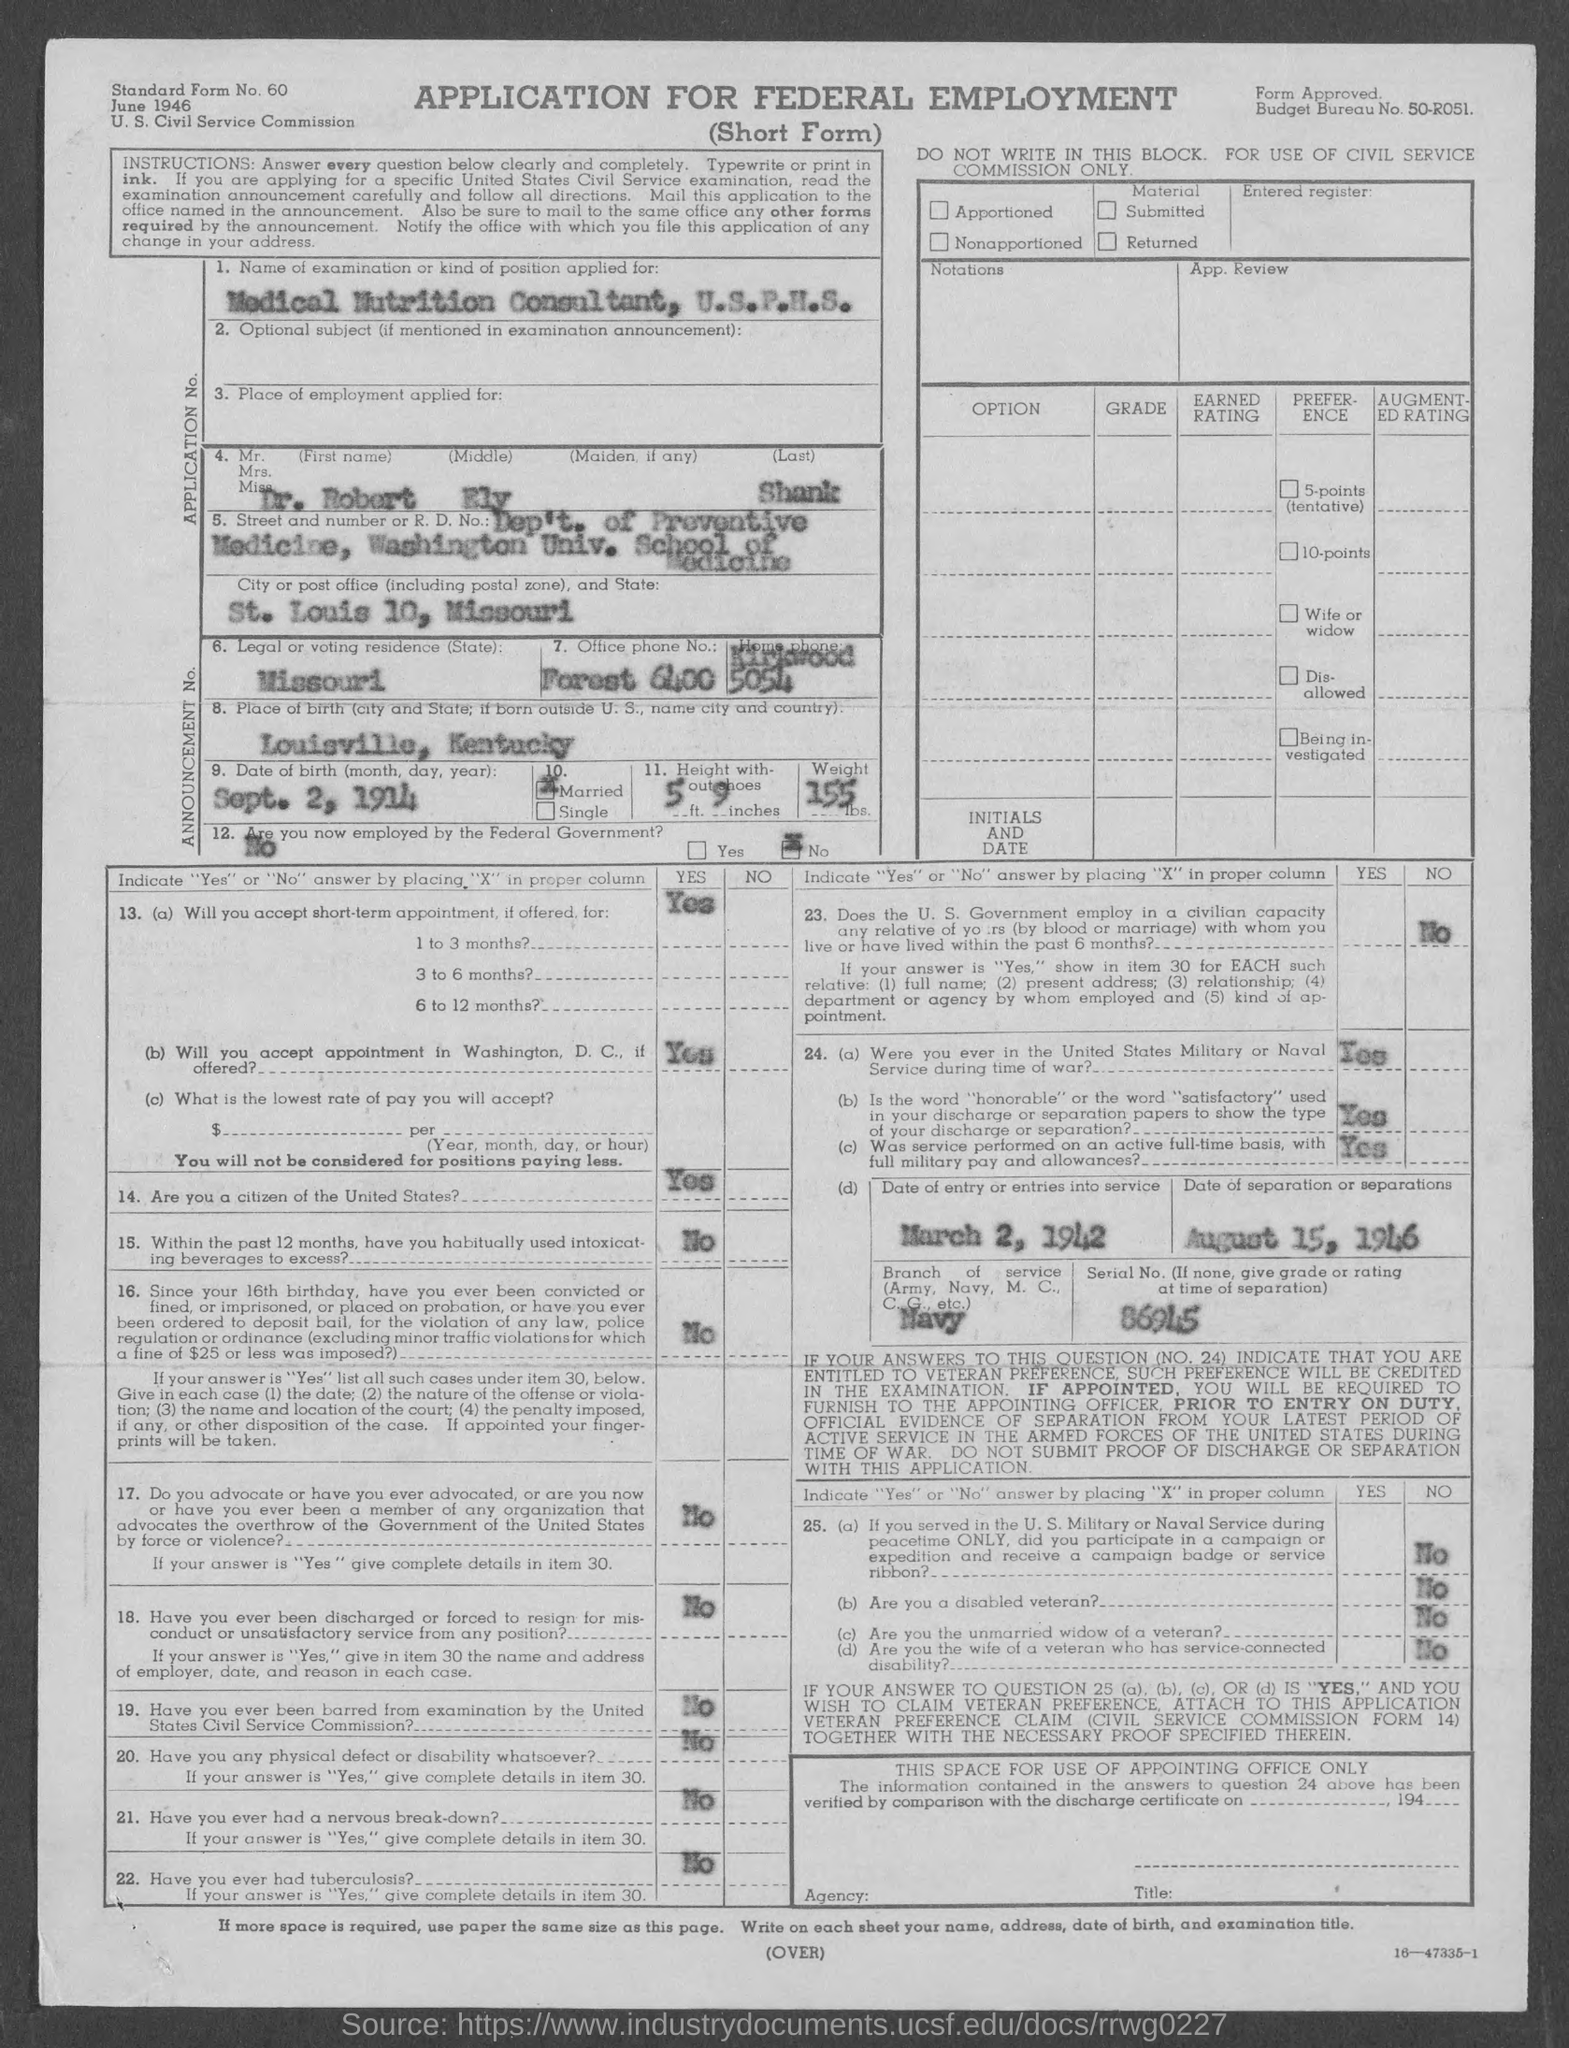Draw attention to some important aspects in this diagram. The applicant is not currently employed by the federal government. The birthplace of the applicant is Louisville, Kentucky. The applicant is married," the declaration states. The serial number is 86945... if none, give grade or rating at time of separation. The date of birth of the applicant is September 2, 1914. 